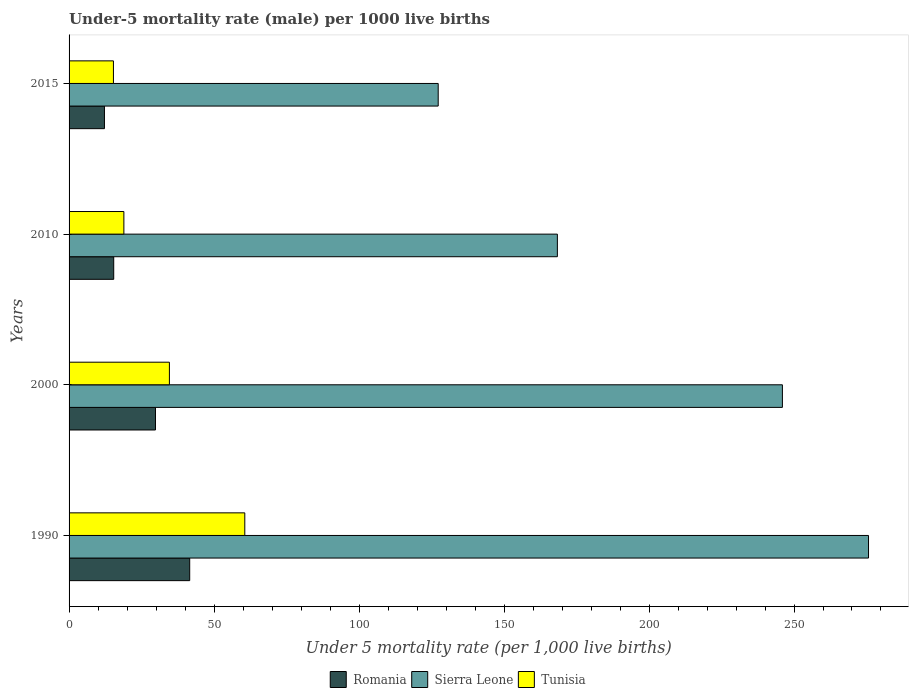Are the number of bars per tick equal to the number of legend labels?
Your answer should be compact. Yes. Are the number of bars on each tick of the Y-axis equal?
Give a very brief answer. Yes. How many bars are there on the 1st tick from the bottom?
Your answer should be very brief. 3. In how many cases, is the number of bars for a given year not equal to the number of legend labels?
Make the answer very short. 0. What is the under-five mortality rate in Sierra Leone in 1990?
Make the answer very short. 275.7. Across all years, what is the maximum under-five mortality rate in Tunisia?
Your answer should be very brief. 60.6. In which year was the under-five mortality rate in Tunisia maximum?
Offer a terse response. 1990. In which year was the under-five mortality rate in Sierra Leone minimum?
Your answer should be compact. 2015. What is the total under-five mortality rate in Sierra Leone in the graph?
Your answer should be very brief. 817.4. What is the difference between the under-five mortality rate in Tunisia in 2010 and that in 2015?
Your response must be concise. 3.6. What is the difference between the under-five mortality rate in Sierra Leone in 2010 and the under-five mortality rate in Romania in 2015?
Your answer should be very brief. 156.2. What is the average under-five mortality rate in Tunisia per year?
Offer a very short reply. 32.35. In the year 2015, what is the difference between the under-five mortality rate in Sierra Leone and under-five mortality rate in Romania?
Offer a very short reply. 115.1. In how many years, is the under-five mortality rate in Romania greater than 230 ?
Your answer should be very brief. 0. What is the ratio of the under-five mortality rate in Tunisia in 2000 to that in 2010?
Keep it short and to the point. 1.83. Is the difference between the under-five mortality rate in Sierra Leone in 1990 and 2015 greater than the difference between the under-five mortality rate in Romania in 1990 and 2015?
Make the answer very short. Yes. What is the difference between the highest and the lowest under-five mortality rate in Sierra Leone?
Ensure brevity in your answer.  148.4. In how many years, is the under-five mortality rate in Sierra Leone greater than the average under-five mortality rate in Sierra Leone taken over all years?
Your response must be concise. 2. What does the 2nd bar from the top in 2010 represents?
Your response must be concise. Sierra Leone. What does the 3rd bar from the bottom in 2000 represents?
Your response must be concise. Tunisia. How many bars are there?
Provide a short and direct response. 12. Are the values on the major ticks of X-axis written in scientific E-notation?
Your answer should be very brief. No. Does the graph contain any zero values?
Your response must be concise. No. Does the graph contain grids?
Ensure brevity in your answer.  No. What is the title of the graph?
Keep it short and to the point. Under-5 mortality rate (male) per 1000 live births. Does "Hong Kong" appear as one of the legend labels in the graph?
Your response must be concise. No. What is the label or title of the X-axis?
Your response must be concise. Under 5 mortality rate (per 1,0 live births). What is the Under 5 mortality rate (per 1,000 live births) in Romania in 1990?
Keep it short and to the point. 41.6. What is the Under 5 mortality rate (per 1,000 live births) of Sierra Leone in 1990?
Provide a short and direct response. 275.7. What is the Under 5 mortality rate (per 1,000 live births) of Tunisia in 1990?
Offer a very short reply. 60.6. What is the Under 5 mortality rate (per 1,000 live births) of Romania in 2000?
Your response must be concise. 29.8. What is the Under 5 mortality rate (per 1,000 live births) of Sierra Leone in 2000?
Keep it short and to the point. 246. What is the Under 5 mortality rate (per 1,000 live births) in Tunisia in 2000?
Your response must be concise. 34.6. What is the Under 5 mortality rate (per 1,000 live births) of Sierra Leone in 2010?
Give a very brief answer. 168.4. What is the Under 5 mortality rate (per 1,000 live births) in Romania in 2015?
Make the answer very short. 12.2. What is the Under 5 mortality rate (per 1,000 live births) in Sierra Leone in 2015?
Offer a terse response. 127.3. Across all years, what is the maximum Under 5 mortality rate (per 1,000 live births) of Romania?
Offer a very short reply. 41.6. Across all years, what is the maximum Under 5 mortality rate (per 1,000 live births) of Sierra Leone?
Ensure brevity in your answer.  275.7. Across all years, what is the maximum Under 5 mortality rate (per 1,000 live births) of Tunisia?
Keep it short and to the point. 60.6. Across all years, what is the minimum Under 5 mortality rate (per 1,000 live births) of Sierra Leone?
Give a very brief answer. 127.3. Across all years, what is the minimum Under 5 mortality rate (per 1,000 live births) in Tunisia?
Provide a short and direct response. 15.3. What is the total Under 5 mortality rate (per 1,000 live births) of Sierra Leone in the graph?
Offer a very short reply. 817.4. What is the total Under 5 mortality rate (per 1,000 live births) of Tunisia in the graph?
Ensure brevity in your answer.  129.4. What is the difference between the Under 5 mortality rate (per 1,000 live births) of Romania in 1990 and that in 2000?
Your answer should be compact. 11.8. What is the difference between the Under 5 mortality rate (per 1,000 live births) of Sierra Leone in 1990 and that in 2000?
Keep it short and to the point. 29.7. What is the difference between the Under 5 mortality rate (per 1,000 live births) of Tunisia in 1990 and that in 2000?
Offer a terse response. 26. What is the difference between the Under 5 mortality rate (per 1,000 live births) of Romania in 1990 and that in 2010?
Your response must be concise. 26.2. What is the difference between the Under 5 mortality rate (per 1,000 live births) of Sierra Leone in 1990 and that in 2010?
Your answer should be very brief. 107.3. What is the difference between the Under 5 mortality rate (per 1,000 live births) of Tunisia in 1990 and that in 2010?
Keep it short and to the point. 41.7. What is the difference between the Under 5 mortality rate (per 1,000 live births) of Romania in 1990 and that in 2015?
Give a very brief answer. 29.4. What is the difference between the Under 5 mortality rate (per 1,000 live births) in Sierra Leone in 1990 and that in 2015?
Provide a short and direct response. 148.4. What is the difference between the Under 5 mortality rate (per 1,000 live births) in Tunisia in 1990 and that in 2015?
Offer a terse response. 45.3. What is the difference between the Under 5 mortality rate (per 1,000 live births) of Sierra Leone in 2000 and that in 2010?
Offer a terse response. 77.6. What is the difference between the Under 5 mortality rate (per 1,000 live births) in Tunisia in 2000 and that in 2010?
Keep it short and to the point. 15.7. What is the difference between the Under 5 mortality rate (per 1,000 live births) of Romania in 2000 and that in 2015?
Offer a very short reply. 17.6. What is the difference between the Under 5 mortality rate (per 1,000 live births) in Sierra Leone in 2000 and that in 2015?
Make the answer very short. 118.7. What is the difference between the Under 5 mortality rate (per 1,000 live births) of Tunisia in 2000 and that in 2015?
Your response must be concise. 19.3. What is the difference between the Under 5 mortality rate (per 1,000 live births) in Sierra Leone in 2010 and that in 2015?
Your answer should be compact. 41.1. What is the difference between the Under 5 mortality rate (per 1,000 live births) of Tunisia in 2010 and that in 2015?
Your answer should be compact. 3.6. What is the difference between the Under 5 mortality rate (per 1,000 live births) of Romania in 1990 and the Under 5 mortality rate (per 1,000 live births) of Sierra Leone in 2000?
Provide a short and direct response. -204.4. What is the difference between the Under 5 mortality rate (per 1,000 live births) in Romania in 1990 and the Under 5 mortality rate (per 1,000 live births) in Tunisia in 2000?
Your answer should be very brief. 7. What is the difference between the Under 5 mortality rate (per 1,000 live births) of Sierra Leone in 1990 and the Under 5 mortality rate (per 1,000 live births) of Tunisia in 2000?
Offer a terse response. 241.1. What is the difference between the Under 5 mortality rate (per 1,000 live births) in Romania in 1990 and the Under 5 mortality rate (per 1,000 live births) in Sierra Leone in 2010?
Provide a succinct answer. -126.8. What is the difference between the Under 5 mortality rate (per 1,000 live births) of Romania in 1990 and the Under 5 mortality rate (per 1,000 live births) of Tunisia in 2010?
Provide a succinct answer. 22.7. What is the difference between the Under 5 mortality rate (per 1,000 live births) of Sierra Leone in 1990 and the Under 5 mortality rate (per 1,000 live births) of Tunisia in 2010?
Provide a succinct answer. 256.8. What is the difference between the Under 5 mortality rate (per 1,000 live births) in Romania in 1990 and the Under 5 mortality rate (per 1,000 live births) in Sierra Leone in 2015?
Your response must be concise. -85.7. What is the difference between the Under 5 mortality rate (per 1,000 live births) in Romania in 1990 and the Under 5 mortality rate (per 1,000 live births) in Tunisia in 2015?
Make the answer very short. 26.3. What is the difference between the Under 5 mortality rate (per 1,000 live births) in Sierra Leone in 1990 and the Under 5 mortality rate (per 1,000 live births) in Tunisia in 2015?
Give a very brief answer. 260.4. What is the difference between the Under 5 mortality rate (per 1,000 live births) in Romania in 2000 and the Under 5 mortality rate (per 1,000 live births) in Sierra Leone in 2010?
Your answer should be very brief. -138.6. What is the difference between the Under 5 mortality rate (per 1,000 live births) of Romania in 2000 and the Under 5 mortality rate (per 1,000 live births) of Tunisia in 2010?
Your answer should be very brief. 10.9. What is the difference between the Under 5 mortality rate (per 1,000 live births) in Sierra Leone in 2000 and the Under 5 mortality rate (per 1,000 live births) in Tunisia in 2010?
Keep it short and to the point. 227.1. What is the difference between the Under 5 mortality rate (per 1,000 live births) of Romania in 2000 and the Under 5 mortality rate (per 1,000 live births) of Sierra Leone in 2015?
Provide a short and direct response. -97.5. What is the difference between the Under 5 mortality rate (per 1,000 live births) of Sierra Leone in 2000 and the Under 5 mortality rate (per 1,000 live births) of Tunisia in 2015?
Ensure brevity in your answer.  230.7. What is the difference between the Under 5 mortality rate (per 1,000 live births) in Romania in 2010 and the Under 5 mortality rate (per 1,000 live births) in Sierra Leone in 2015?
Provide a succinct answer. -111.9. What is the difference between the Under 5 mortality rate (per 1,000 live births) of Sierra Leone in 2010 and the Under 5 mortality rate (per 1,000 live births) of Tunisia in 2015?
Give a very brief answer. 153.1. What is the average Under 5 mortality rate (per 1,000 live births) of Romania per year?
Ensure brevity in your answer.  24.75. What is the average Under 5 mortality rate (per 1,000 live births) in Sierra Leone per year?
Your answer should be very brief. 204.35. What is the average Under 5 mortality rate (per 1,000 live births) of Tunisia per year?
Your answer should be compact. 32.35. In the year 1990, what is the difference between the Under 5 mortality rate (per 1,000 live births) in Romania and Under 5 mortality rate (per 1,000 live births) in Sierra Leone?
Provide a succinct answer. -234.1. In the year 1990, what is the difference between the Under 5 mortality rate (per 1,000 live births) in Sierra Leone and Under 5 mortality rate (per 1,000 live births) in Tunisia?
Ensure brevity in your answer.  215.1. In the year 2000, what is the difference between the Under 5 mortality rate (per 1,000 live births) of Romania and Under 5 mortality rate (per 1,000 live births) of Sierra Leone?
Make the answer very short. -216.2. In the year 2000, what is the difference between the Under 5 mortality rate (per 1,000 live births) in Sierra Leone and Under 5 mortality rate (per 1,000 live births) in Tunisia?
Offer a very short reply. 211.4. In the year 2010, what is the difference between the Under 5 mortality rate (per 1,000 live births) of Romania and Under 5 mortality rate (per 1,000 live births) of Sierra Leone?
Provide a short and direct response. -153. In the year 2010, what is the difference between the Under 5 mortality rate (per 1,000 live births) in Romania and Under 5 mortality rate (per 1,000 live births) in Tunisia?
Your answer should be compact. -3.5. In the year 2010, what is the difference between the Under 5 mortality rate (per 1,000 live births) in Sierra Leone and Under 5 mortality rate (per 1,000 live births) in Tunisia?
Offer a terse response. 149.5. In the year 2015, what is the difference between the Under 5 mortality rate (per 1,000 live births) of Romania and Under 5 mortality rate (per 1,000 live births) of Sierra Leone?
Offer a terse response. -115.1. In the year 2015, what is the difference between the Under 5 mortality rate (per 1,000 live births) in Romania and Under 5 mortality rate (per 1,000 live births) in Tunisia?
Offer a terse response. -3.1. In the year 2015, what is the difference between the Under 5 mortality rate (per 1,000 live births) in Sierra Leone and Under 5 mortality rate (per 1,000 live births) in Tunisia?
Give a very brief answer. 112. What is the ratio of the Under 5 mortality rate (per 1,000 live births) of Romania in 1990 to that in 2000?
Your answer should be very brief. 1.4. What is the ratio of the Under 5 mortality rate (per 1,000 live births) of Sierra Leone in 1990 to that in 2000?
Your answer should be compact. 1.12. What is the ratio of the Under 5 mortality rate (per 1,000 live births) of Tunisia in 1990 to that in 2000?
Offer a terse response. 1.75. What is the ratio of the Under 5 mortality rate (per 1,000 live births) in Romania in 1990 to that in 2010?
Your response must be concise. 2.7. What is the ratio of the Under 5 mortality rate (per 1,000 live births) of Sierra Leone in 1990 to that in 2010?
Provide a succinct answer. 1.64. What is the ratio of the Under 5 mortality rate (per 1,000 live births) in Tunisia in 1990 to that in 2010?
Ensure brevity in your answer.  3.21. What is the ratio of the Under 5 mortality rate (per 1,000 live births) in Romania in 1990 to that in 2015?
Your answer should be very brief. 3.41. What is the ratio of the Under 5 mortality rate (per 1,000 live births) in Sierra Leone in 1990 to that in 2015?
Provide a short and direct response. 2.17. What is the ratio of the Under 5 mortality rate (per 1,000 live births) in Tunisia in 1990 to that in 2015?
Make the answer very short. 3.96. What is the ratio of the Under 5 mortality rate (per 1,000 live births) of Romania in 2000 to that in 2010?
Provide a succinct answer. 1.94. What is the ratio of the Under 5 mortality rate (per 1,000 live births) of Sierra Leone in 2000 to that in 2010?
Offer a very short reply. 1.46. What is the ratio of the Under 5 mortality rate (per 1,000 live births) in Tunisia in 2000 to that in 2010?
Your answer should be compact. 1.83. What is the ratio of the Under 5 mortality rate (per 1,000 live births) of Romania in 2000 to that in 2015?
Your response must be concise. 2.44. What is the ratio of the Under 5 mortality rate (per 1,000 live births) of Sierra Leone in 2000 to that in 2015?
Offer a terse response. 1.93. What is the ratio of the Under 5 mortality rate (per 1,000 live births) of Tunisia in 2000 to that in 2015?
Your answer should be very brief. 2.26. What is the ratio of the Under 5 mortality rate (per 1,000 live births) in Romania in 2010 to that in 2015?
Make the answer very short. 1.26. What is the ratio of the Under 5 mortality rate (per 1,000 live births) in Sierra Leone in 2010 to that in 2015?
Your answer should be very brief. 1.32. What is the ratio of the Under 5 mortality rate (per 1,000 live births) in Tunisia in 2010 to that in 2015?
Provide a short and direct response. 1.24. What is the difference between the highest and the second highest Under 5 mortality rate (per 1,000 live births) of Sierra Leone?
Give a very brief answer. 29.7. What is the difference between the highest and the second highest Under 5 mortality rate (per 1,000 live births) of Tunisia?
Provide a succinct answer. 26. What is the difference between the highest and the lowest Under 5 mortality rate (per 1,000 live births) of Romania?
Provide a succinct answer. 29.4. What is the difference between the highest and the lowest Under 5 mortality rate (per 1,000 live births) in Sierra Leone?
Offer a terse response. 148.4. What is the difference between the highest and the lowest Under 5 mortality rate (per 1,000 live births) in Tunisia?
Give a very brief answer. 45.3. 